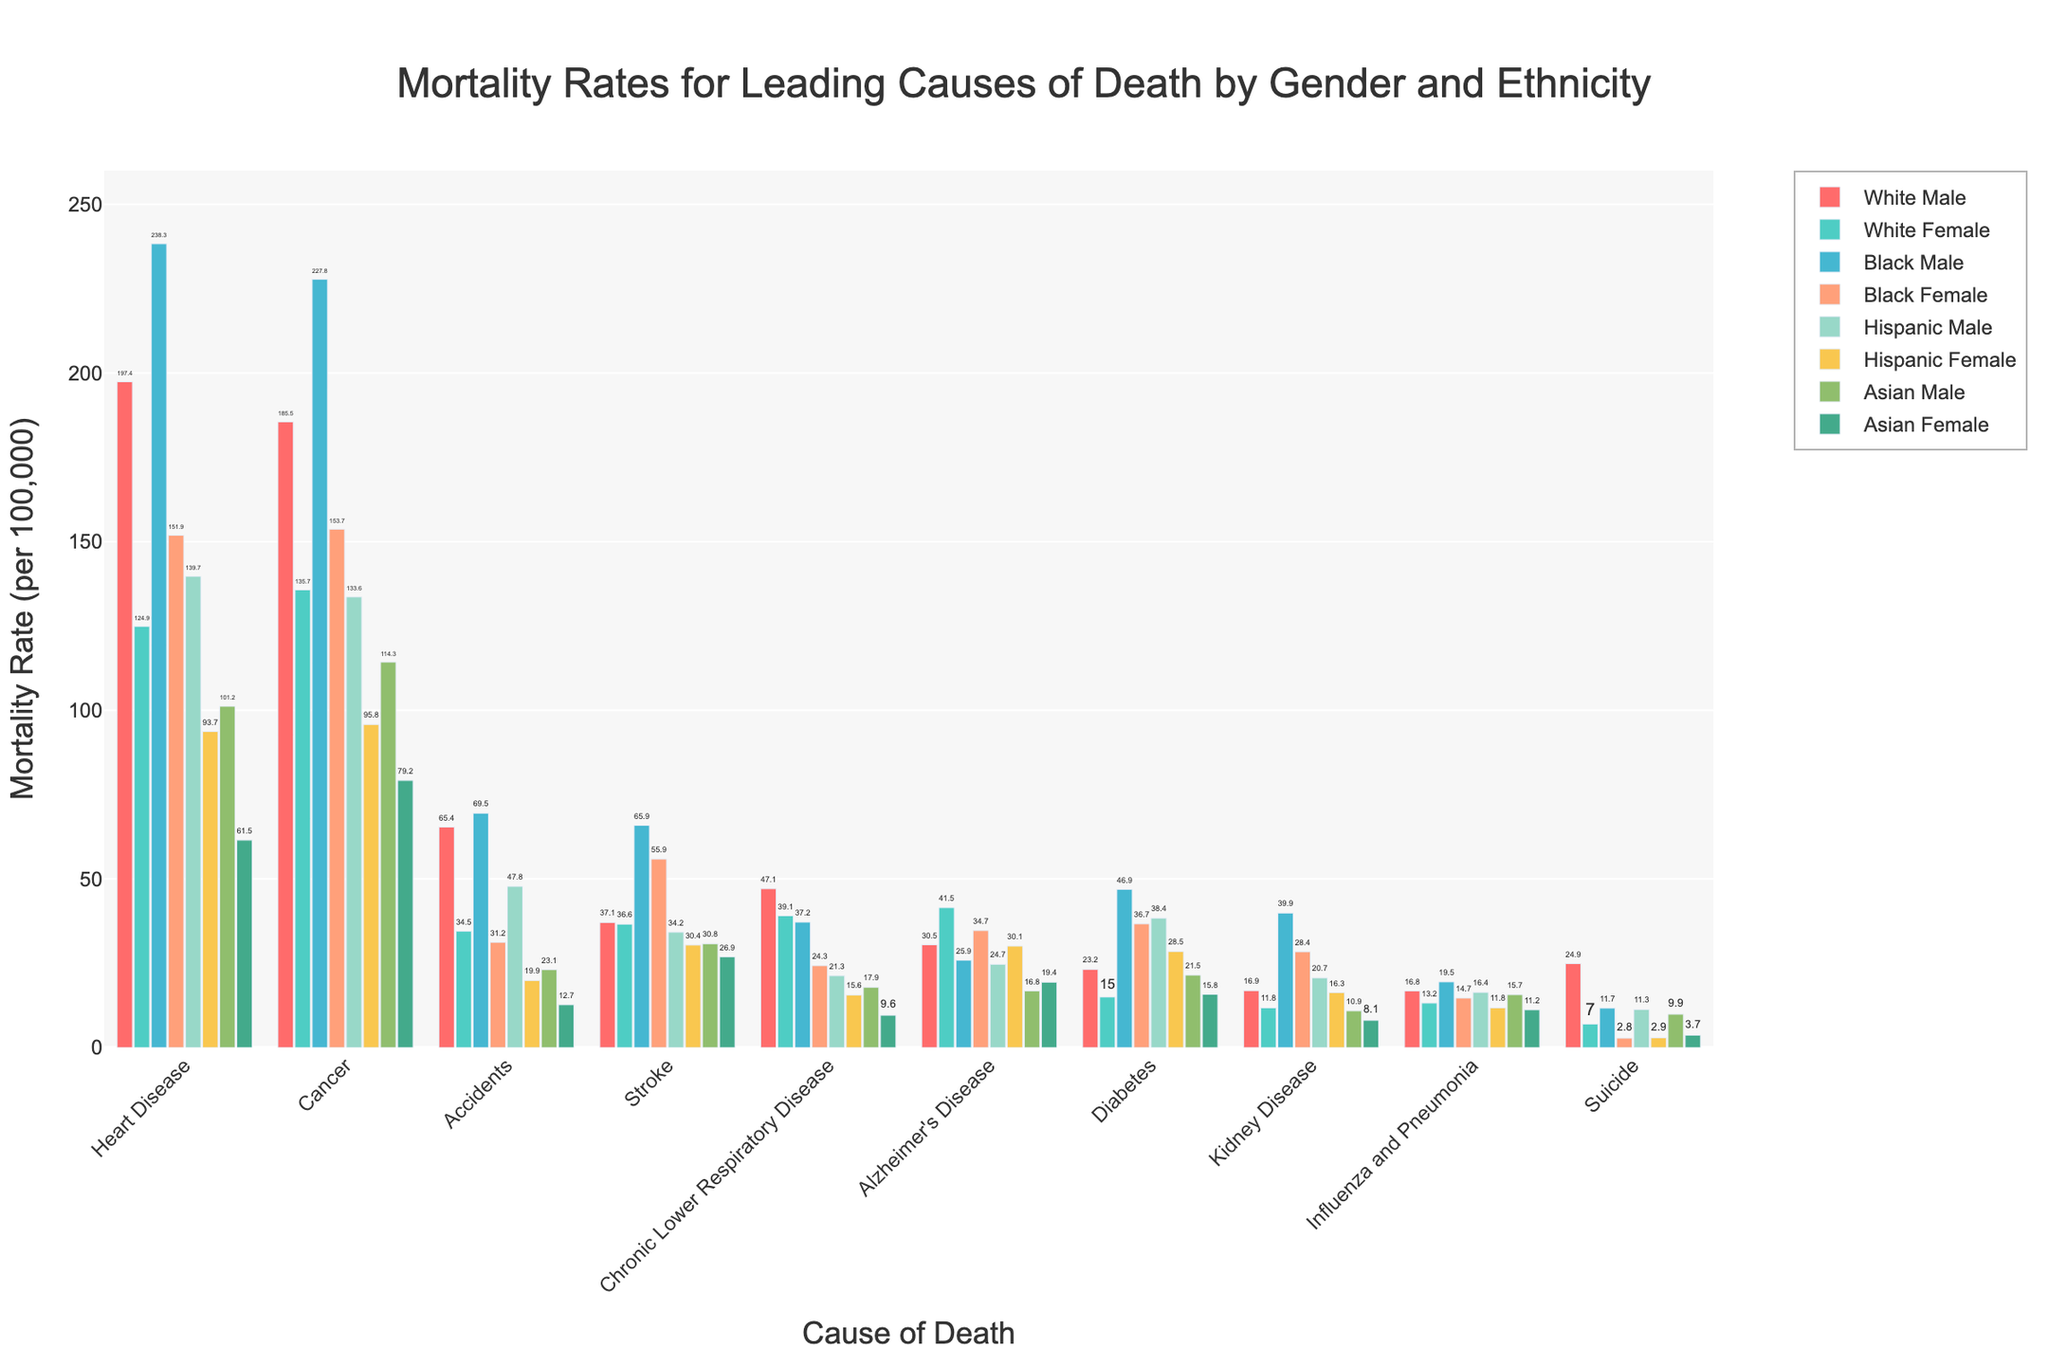Which ethnicity and gender have the highest mortality rate for heart disease? To find the highest mortality rate for heart disease, look for the highest bar in the heart disease group. The highest value is 238.3 for Black Male.
Answer: Black Male Which ethnicity and gender have the lowest mortality rate for accidents? To determine the lowest rate for accidents, examine the bars in the accidents group and identify the shortest one. The smallest value is 12.7 for Asian Female.
Answer: Asian Female What is the difference in mortality rates between Black Male and Black Female for cancer? Find the bars for cancer corresponding to Black Male and Black Female. The values are 227.8 and 153.7, respectively. Subtract 153.7 from 227.8 to get the difference: 227.8 - 153.7 = 74.1.
Answer: 74.1 Which gender has a higher mortality rate for diabetes within the Hispanic ethnicity? Compare the bars for diabetes for Hispanic Male and Hispanic Female. Hispanic Male has a rate of 38.4, while Hispanic Female has a rate of 28.5. Hispanic Male has a higher rate.
Answer: Hispanic Male What is the total mortality rate for stroke across all ethnicities for females? Sum the stroke mortality rates for all female groups: White Female (36.6) + Black Female (55.9) + Hispanic Female (30.4) + Asian Female (26.9). So, 36.6 + 55.9 + 30.4 + 26.9 = 149.8.
Answer: 149.8 Which ethnicity has the highest combined mortality rate for heart disease and cancer for males? Sum the values of heart disease and cancer for each male ethnicity. Compare the sums: White Male (197.4+185.5=382.9), Black Male (238.3+227.8=466.1), Hispanic Male (139.7+133.6=273.3), Asian Male (101.2+114.3=215.5). The highest is 466.1 for Black Male.
Answer: Black Male Is the mortality rate of chronic lower respiratory disease for White Males greater than that of suicides for White Males? Compare the values for White Males: Chronic Lower Respiratory Disease (47.1) and Suicide (24.9). The value for 47.1 is greater than 24.9.
Answer: Yes Which cause of death has the smallest range of mortality rates across all the groups? Calculate the range (max-min) for each cause and compare: Heart Disease (151.9), Cancer (148.6), Accidents (56.8), Stroke (39), Chronic Lower Respiratory Disease (37.5), Alzheimer’s (25.1), Diabetes (31.9), Kidney Disease (31.8), Influenza and Pneumonia (8.3), Suicide (22.1). The smallest range is for Influenza and Pneumonia with a range of 8.3.
Answer: Influenza and Pneumonia 